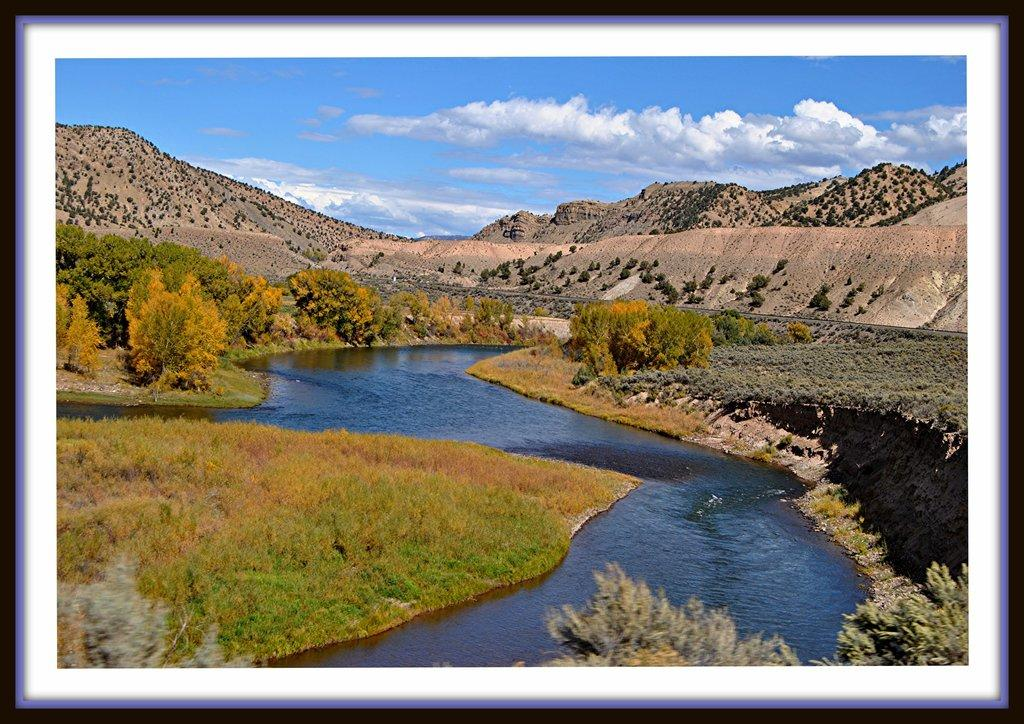What natural element is present in the image? There is water in the image. What type of vegetation can be seen in the image? There is grass, plants, and trees in the image. What geographical feature is visible in the image? There is a mountain in the image. What is visible in the background of the image? The sky is visible in the background of the image. What atmospheric conditions can be observed in the sky? There are clouds in the sky. What color is the balloon in the image? There is no balloon present in the image. What type of thunder can be heard in the image? There is no thunder present in the image, as it is a visual medium and does not convey sound. 